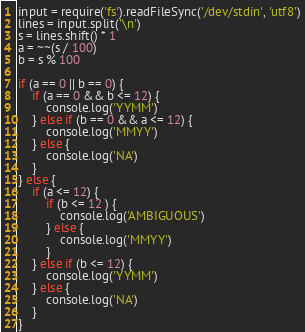<code> <loc_0><loc_0><loc_500><loc_500><_JavaScript_>input = require('fs').readFileSync('/dev/stdin', 'utf8')
lines = input.split('\n') 
s = lines.shift() * 1
a = ~~(s / 100)
b = s % 100 

if (a == 0 || b == 0) {
    if (a == 0 && b <= 12) {
        console.log('YYMM')
    } else if (b == 0 && a <= 12) {
        console.log('MMYY')
    } else {
        console.log('NA')
    }
} else {
    if (a <= 12) {
        if (b <= 12 ) {
            console.log('AMBIGUOUS')
        } else {
            console.log('MMYY')
        } 
    } else if (b <= 12) {
        console.log('YYMM')
    } else {
        console.log('NA')
    }
}
</code> 